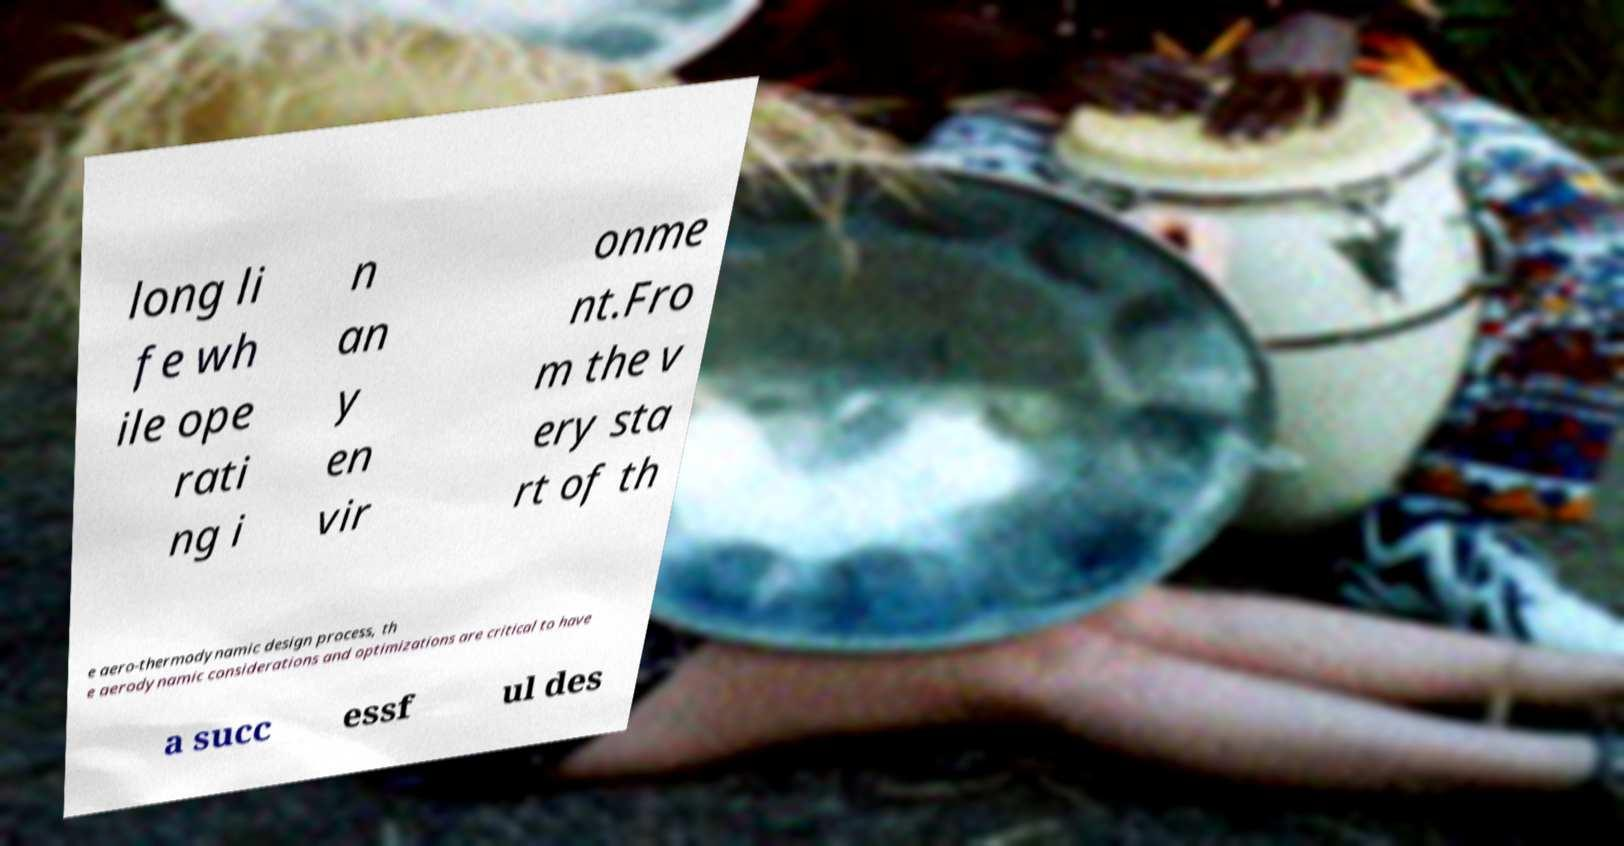There's text embedded in this image that I need extracted. Can you transcribe it verbatim? long li fe wh ile ope rati ng i n an y en vir onme nt.Fro m the v ery sta rt of th e aero-thermodynamic design process, th e aerodynamic considerations and optimizations are critical to have a succ essf ul des 